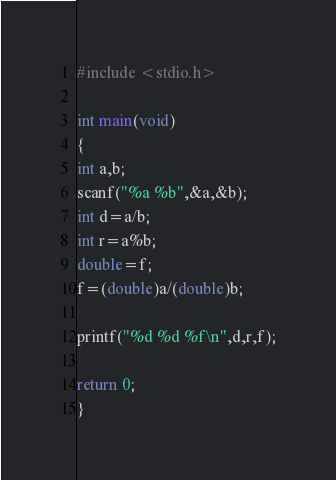Convert code to text. <code><loc_0><loc_0><loc_500><loc_500><_C_>#include <stdio.h>

int main(void)
{
int a,b;
scanf("%a %b",&a,&b);
int d=a/b;
int r=a%b;
double=f;
f=(double)a/(double)b;

printf("%d %d %f\n",d,r,f);

return 0;
}</code> 